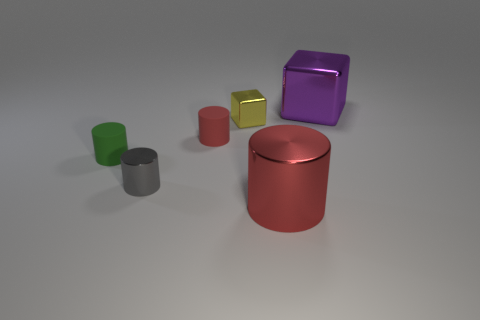Subtract 2 cylinders. How many cylinders are left? 2 Add 3 big cylinders. How many objects exist? 9 Subtract all brown cylinders. Subtract all purple blocks. How many cylinders are left? 4 Subtract all blocks. How many objects are left? 4 Subtract 0 cyan cubes. How many objects are left? 6 Subtract all small brown shiny cylinders. Subtract all yellow metallic objects. How many objects are left? 5 Add 4 tiny yellow metallic blocks. How many tiny yellow metallic blocks are left? 5 Add 4 big red rubber things. How many big red rubber things exist? 4 